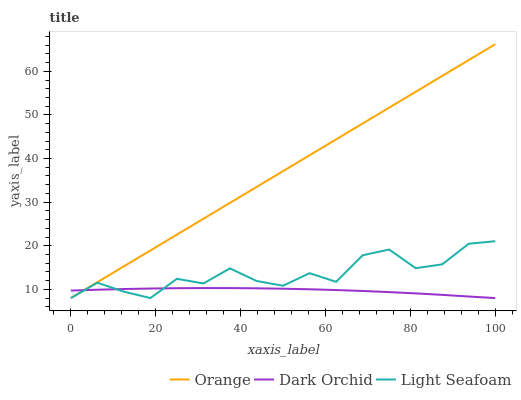Does Dark Orchid have the minimum area under the curve?
Answer yes or no. Yes. Does Orange have the maximum area under the curve?
Answer yes or no. Yes. Does Light Seafoam have the minimum area under the curve?
Answer yes or no. No. Does Light Seafoam have the maximum area under the curve?
Answer yes or no. No. Is Orange the smoothest?
Answer yes or no. Yes. Is Light Seafoam the roughest?
Answer yes or no. Yes. Is Dark Orchid the smoothest?
Answer yes or no. No. Is Dark Orchid the roughest?
Answer yes or no. No. Does Orange have the lowest value?
Answer yes or no. Yes. Does Orange have the highest value?
Answer yes or no. Yes. Does Light Seafoam have the highest value?
Answer yes or no. No. Does Light Seafoam intersect Dark Orchid?
Answer yes or no. Yes. Is Light Seafoam less than Dark Orchid?
Answer yes or no. No. Is Light Seafoam greater than Dark Orchid?
Answer yes or no. No. 